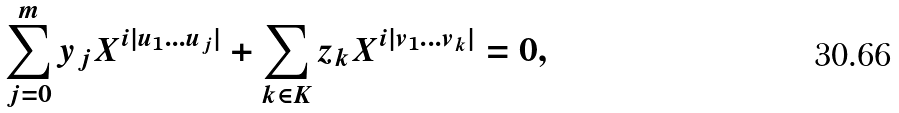Convert formula to latex. <formula><loc_0><loc_0><loc_500><loc_500>\sum _ { j = 0 } ^ { m } y _ { j } X ^ { i | u _ { 1 } \dots u _ { j } | } + \sum _ { k \in K } z _ { k } X ^ { i | v _ { 1 } \dots v _ { k } | } = 0 ,</formula> 